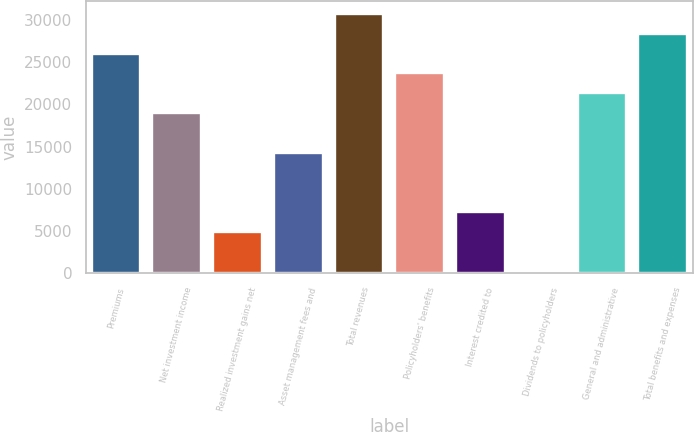Convert chart. <chart><loc_0><loc_0><loc_500><loc_500><bar_chart><fcel>Premiums<fcel>Net investment income<fcel>Realized investment gains net<fcel>Asset management fees and<fcel>Total revenues<fcel>Policyholders' benefits<fcel>Interest credited to<fcel>Dividends to policyholders<fcel>General and administrative<fcel>Total benefits and expenses<nl><fcel>26029.5<fcel>18987<fcel>4902<fcel>14292<fcel>30724.5<fcel>23682<fcel>7249.5<fcel>207<fcel>21334.5<fcel>28377<nl></chart> 